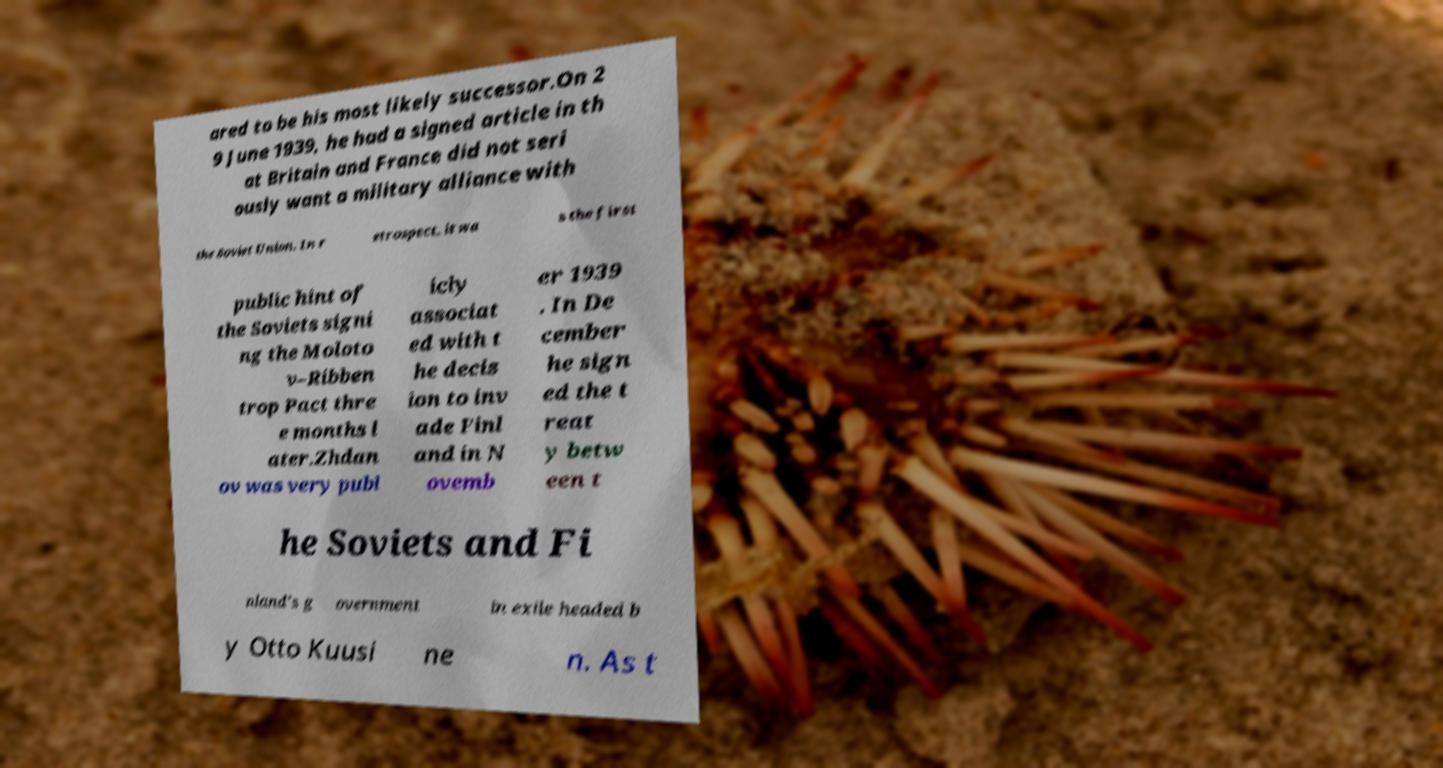I need the written content from this picture converted into text. Can you do that? ared to be his most likely successor.On 2 9 June 1939, he had a signed article in th at Britain and France did not seri ously want a military alliance with the Soviet Union. In r etrospect, it wa s the first public hint of the Soviets signi ng the Moloto v–Ribben trop Pact thre e months l ater.Zhdan ov was very publ icly associat ed with t he decis ion to inv ade Finl and in N ovemb er 1939 . In De cember he sign ed the t reat y betw een t he Soviets and Fi nland's g overnment in exile headed b y Otto Kuusi ne n. As t 